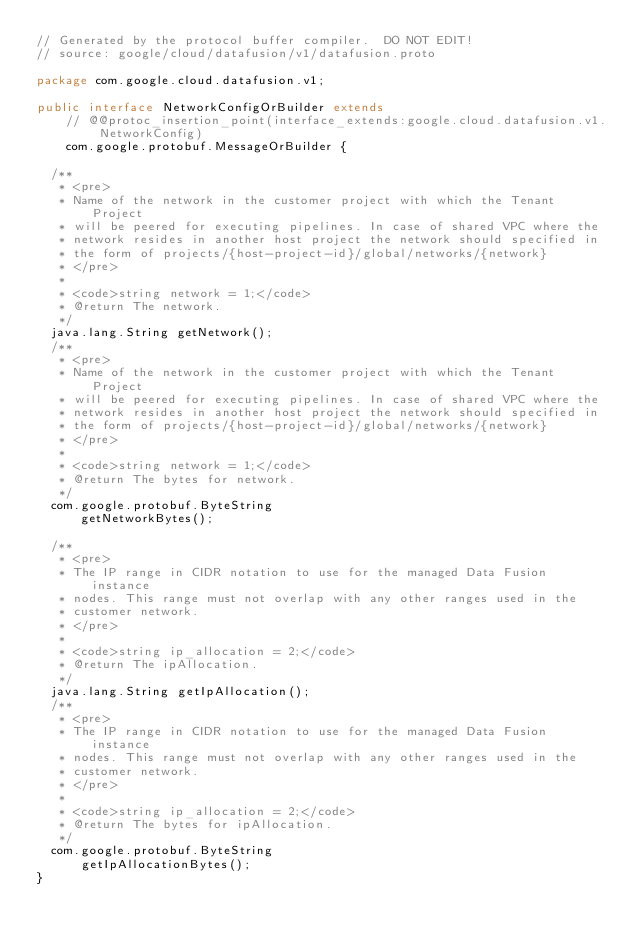<code> <loc_0><loc_0><loc_500><loc_500><_Java_>// Generated by the protocol buffer compiler.  DO NOT EDIT!
// source: google/cloud/datafusion/v1/datafusion.proto

package com.google.cloud.datafusion.v1;

public interface NetworkConfigOrBuilder extends
    // @@protoc_insertion_point(interface_extends:google.cloud.datafusion.v1.NetworkConfig)
    com.google.protobuf.MessageOrBuilder {

  /**
   * <pre>
   * Name of the network in the customer project with which the Tenant Project
   * will be peered for executing pipelines. In case of shared VPC where the
   * network resides in another host project the network should specified in
   * the form of projects/{host-project-id}/global/networks/{network}
   * </pre>
   *
   * <code>string network = 1;</code>
   * @return The network.
   */
  java.lang.String getNetwork();
  /**
   * <pre>
   * Name of the network in the customer project with which the Tenant Project
   * will be peered for executing pipelines. In case of shared VPC where the
   * network resides in another host project the network should specified in
   * the form of projects/{host-project-id}/global/networks/{network}
   * </pre>
   *
   * <code>string network = 1;</code>
   * @return The bytes for network.
   */
  com.google.protobuf.ByteString
      getNetworkBytes();

  /**
   * <pre>
   * The IP range in CIDR notation to use for the managed Data Fusion instance
   * nodes. This range must not overlap with any other ranges used in the
   * customer network.
   * </pre>
   *
   * <code>string ip_allocation = 2;</code>
   * @return The ipAllocation.
   */
  java.lang.String getIpAllocation();
  /**
   * <pre>
   * The IP range in CIDR notation to use for the managed Data Fusion instance
   * nodes. This range must not overlap with any other ranges used in the
   * customer network.
   * </pre>
   *
   * <code>string ip_allocation = 2;</code>
   * @return The bytes for ipAllocation.
   */
  com.google.protobuf.ByteString
      getIpAllocationBytes();
}
</code> 